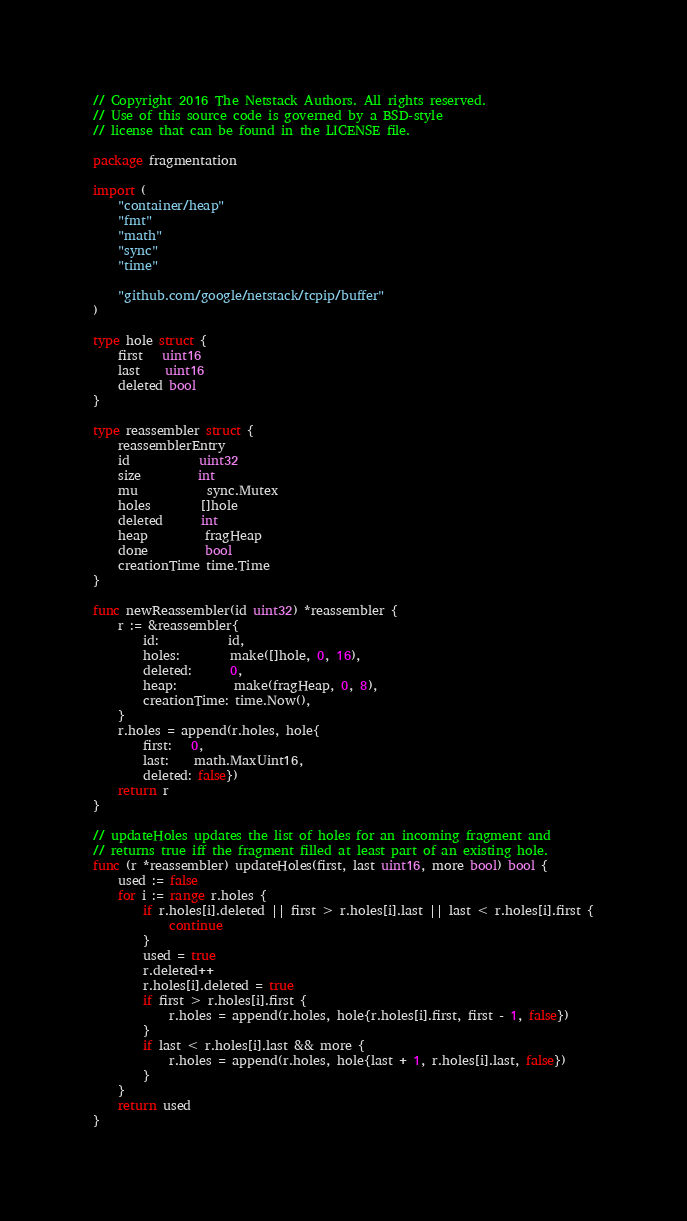Convert code to text. <code><loc_0><loc_0><loc_500><loc_500><_Go_>// Copyright 2016 The Netstack Authors. All rights reserved.
// Use of this source code is governed by a BSD-style
// license that can be found in the LICENSE file.

package fragmentation

import (
	"container/heap"
	"fmt"
	"math"
	"sync"
	"time"

	"github.com/google/netstack/tcpip/buffer"
)

type hole struct {
	first   uint16
	last    uint16
	deleted bool
}

type reassembler struct {
	reassemblerEntry
	id           uint32
	size         int
	mu           sync.Mutex
	holes        []hole
	deleted      int
	heap         fragHeap
	done         bool
	creationTime time.Time
}

func newReassembler(id uint32) *reassembler {
	r := &reassembler{
		id:           id,
		holes:        make([]hole, 0, 16),
		deleted:      0,
		heap:         make(fragHeap, 0, 8),
		creationTime: time.Now(),
	}
	r.holes = append(r.holes, hole{
		first:   0,
		last:    math.MaxUint16,
		deleted: false})
	return r
}

// updateHoles updates the list of holes for an incoming fragment and
// returns true iff the fragment filled at least part of an existing hole.
func (r *reassembler) updateHoles(first, last uint16, more bool) bool {
	used := false
	for i := range r.holes {
		if r.holes[i].deleted || first > r.holes[i].last || last < r.holes[i].first {
			continue
		}
		used = true
		r.deleted++
		r.holes[i].deleted = true
		if first > r.holes[i].first {
			r.holes = append(r.holes, hole{r.holes[i].first, first - 1, false})
		}
		if last < r.holes[i].last && more {
			r.holes = append(r.holes, hole{last + 1, r.holes[i].last, false})
		}
	}
	return used
}
</code> 